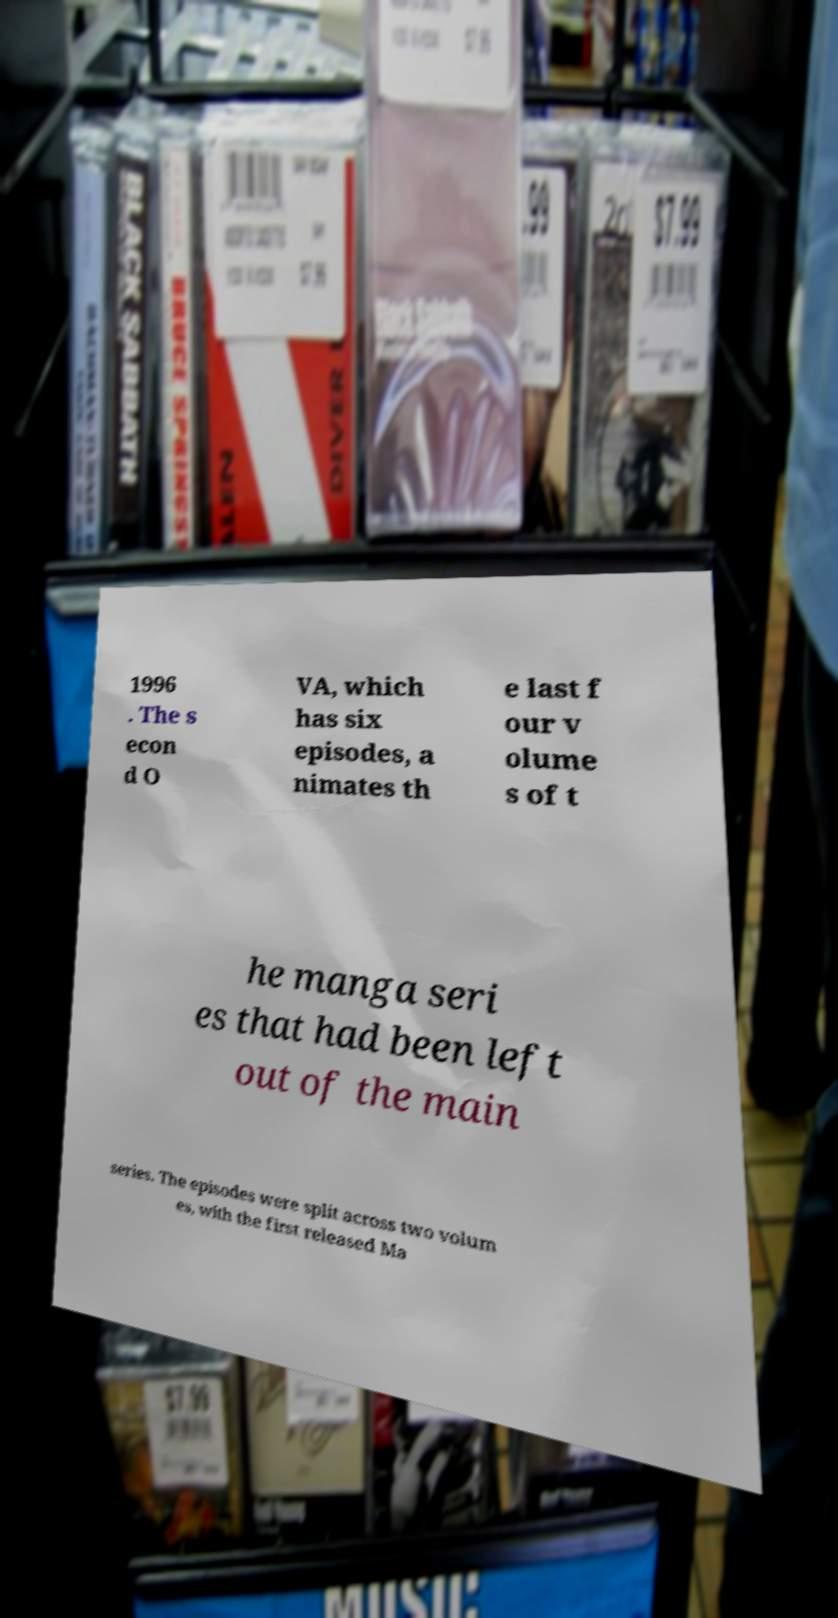Could you assist in decoding the text presented in this image and type it out clearly? 1996 . The s econ d O VA, which has six episodes, a nimates th e last f our v olume s of t he manga seri es that had been left out of the main series. The episodes were split across two volum es, with the first released Ma 